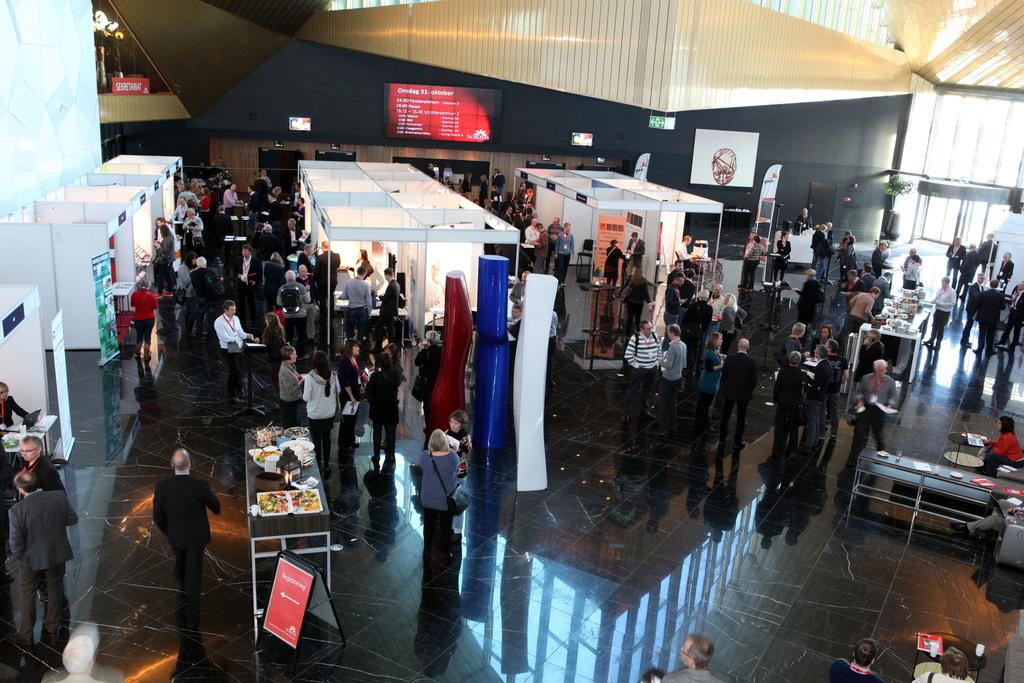How many people are present in the image? There are people in the image, but the exact number is not specified. What type of structures can be seen in the image? There are hoardings, boards, stalls, and tables visible in the image. What type of objects are used for serving food in the image? There are plates and bowls in the image for serving food. What type of vegetation is present in the image? There are trees in the image. What type of food items can be seen in the image? There are food items in the image. What is visible in the background of the image? There is a wall and lights visible in the background of the image. How many spiders are crawling on the plates in the image? There are no spiders present in the image; it features people, hoardings, boards, stalls, tables, plates, bowls, trees, food items, unspecified objects, a wall, and lights. What type of journey are the people taking in the image? There is no indication of a journey in the image; it shows people in a setting with various structures and objects. 